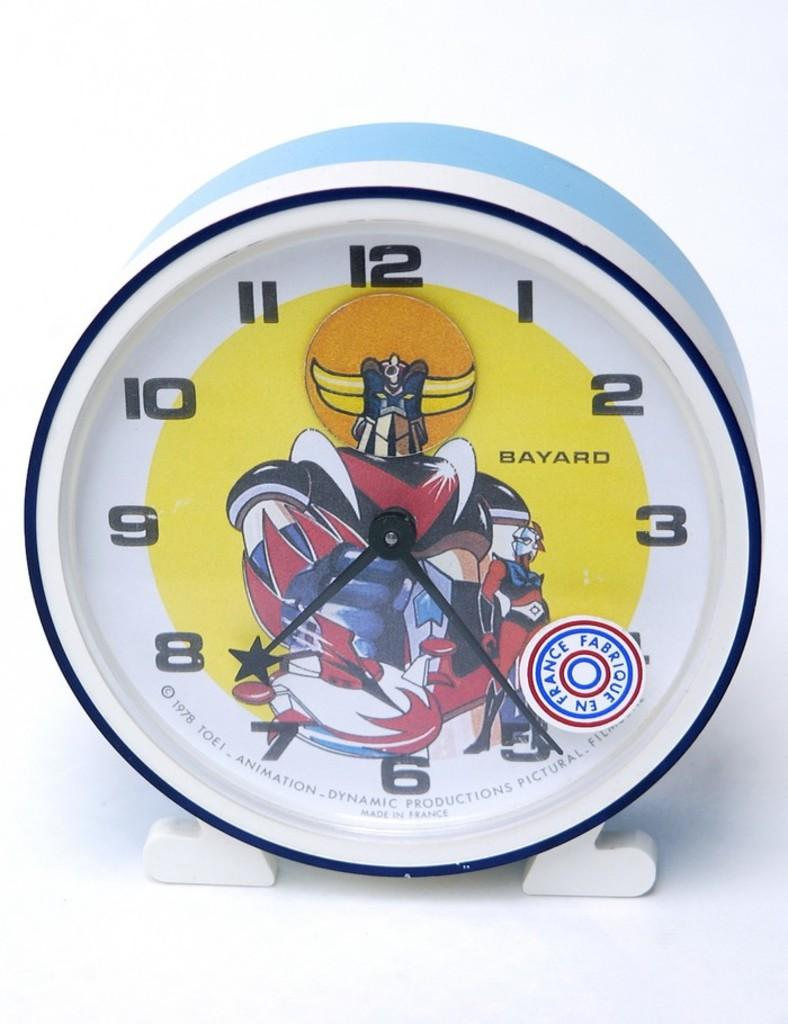Provide a one-sentence caption for the provided image. Clock from Bayard that is white, black, and blue. 